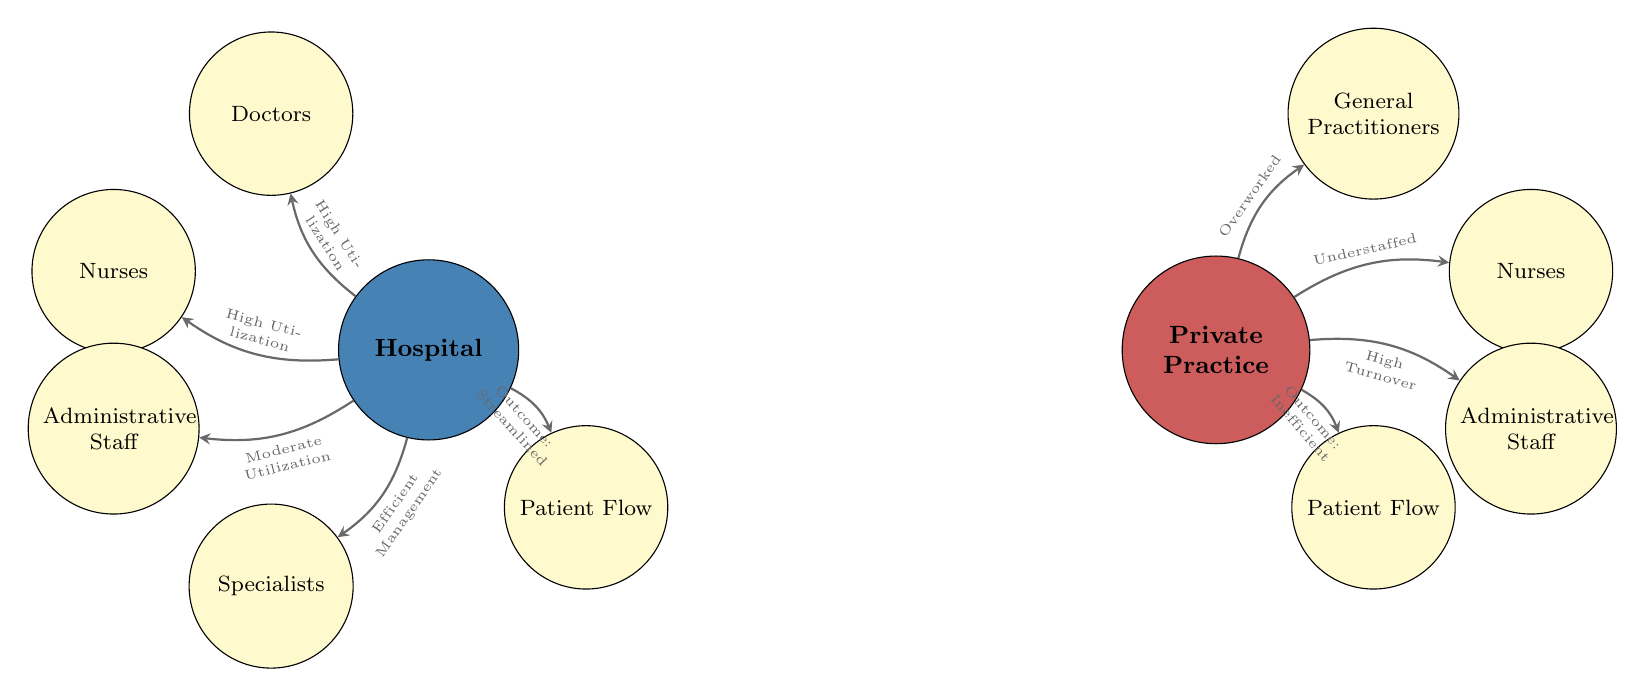What is positioned at the top of the hospital node? The "Doctors" group is located above the Hospital node, indicating a high utilization of their services.
Answer: Doctors How many groups are associated with the Hospital node? There are five groups linked to the Hospital node: Doctors, Nurses, Administrative Staff, Specialists, and Patient Flow.
Answer: 5 What is indicated by the edge between the Hospital and the Specialists group? The edge indicates "Efficient Management," suggesting that specialists are managed effectively in the hospital setting.
Answer: Efficient Management What outcome is related to the Private Practice and Patient Flow group? The edge from Private Practice to Patient Flow states "Outcome: Inefficient," highlighting the flow of patients is less effective in this setting.
Answer: Inefficient How are nurses in Private Practice described? The edge links Private Practice to Nurses with the description "Understaffed," showing the issue regarding nursing staff availability.
Answer: Understaffed What feature distinguishes the utilization levels between Hospitals and Private Practices for general practitioners? The diagram indicates that general practitioners in Private Practices are "Overworked," while Hospital doctors have "High Utilization," illustrating different staff workload conditions.
Answer: Overworked What is the contrast between the Administrative Staff nodes in Hospitals versus Private Practices? The Hospital node links to Administrative Staff with "Moderate Utilization," whereas the Private Practice node describes them with "High Turnover," showcasing inefficiency in the private context.
Answer: High Turnover How does Patient Flow differ between the two settings? Patient Flow in the Hospital is streamlined, indicated by the edge that states "Outcome: Streamlined," compared to Private Practice where the outcome is "Inefficient."
Answer: Streamlined What color represents the hospital node in the diagram? The hospital is colored in RGB format as (70,130,180), which corresponds to a specific shade when rendered.
Answer: Hospital Color 